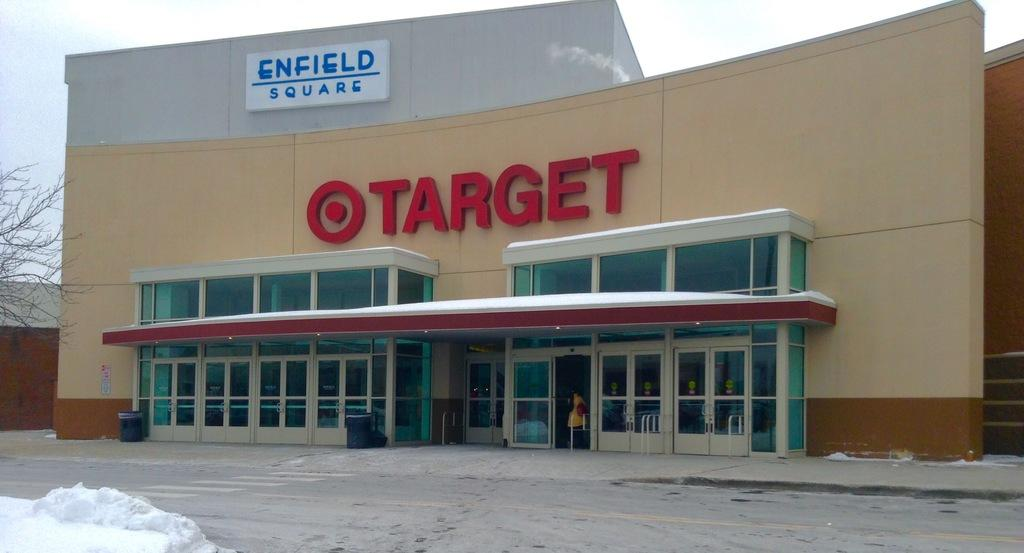What type of structure is present in the image? There is a building in the image. What can be seen on the building? There are boards on the building with text written on them. What is the weather like in the image? There is snow visible in the bottom left of the image, indicating a cold or wintry environment. What type of vegetation is present in the image? There is a tree on the left side of the image. What type of flower is growing on the building in the image? There is no flower growing on the building in the image. Can you see a fan attached to the tree in the image? There is no fan present in the image, either on the building or the tree. 